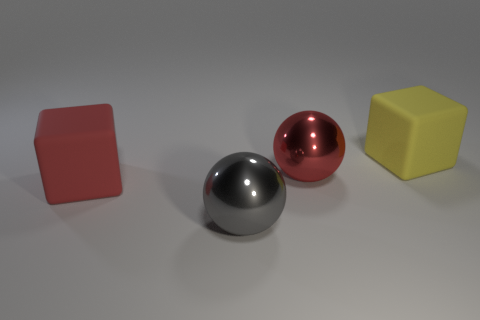Is the yellow cube the same size as the gray ball?
Offer a terse response. Yes. What number of things are either large metal balls or red blocks that are behind the big gray ball?
Offer a terse response. 3. What is the red sphere made of?
Offer a very short reply. Metal. Is the red matte thing the same shape as the red shiny object?
Your answer should be compact. No. There is a cube on the left side of the rubber object behind the red thing that is on the left side of the large gray object; what is its size?
Provide a succinct answer. Large. How many other things are made of the same material as the red block?
Your answer should be compact. 1. There is a large rubber object to the right of the red cube; what color is it?
Your response must be concise. Yellow. What material is the big gray ball that is to the left of the large block that is right of the large metal thing on the right side of the gray metallic ball?
Offer a very short reply. Metal. Is there a gray metal object of the same shape as the big yellow matte thing?
Make the answer very short. No. The yellow rubber thing that is the same size as the gray ball is what shape?
Make the answer very short. Cube. 